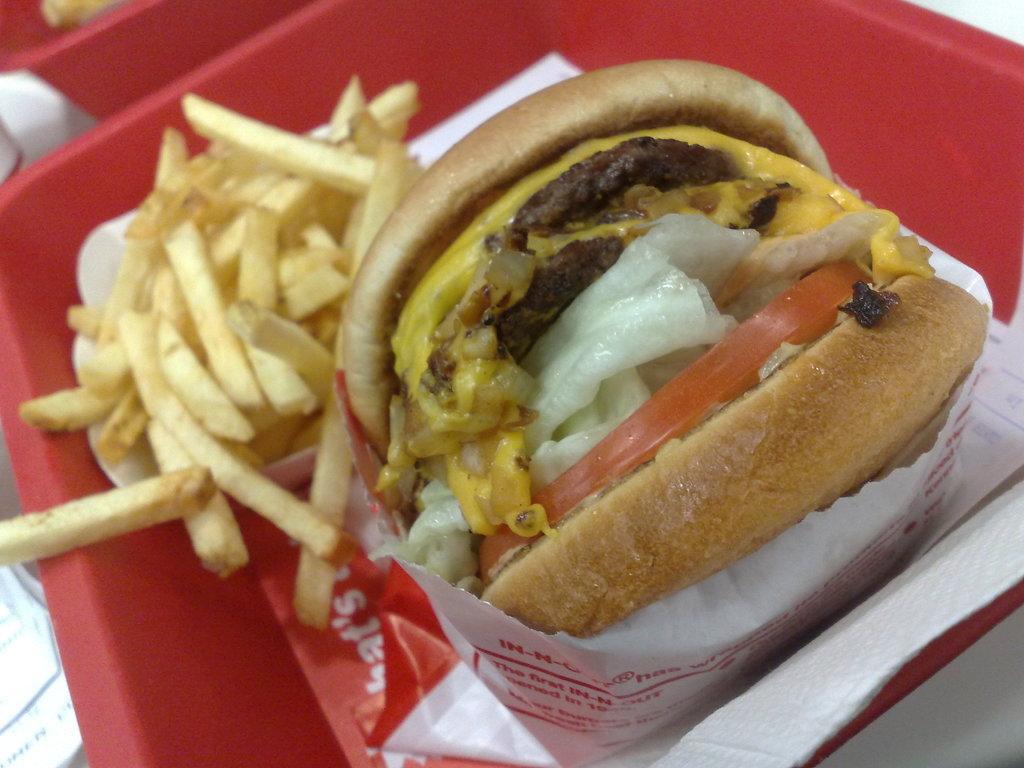Can you describe this image briefly? In this image there is the food in the plate. In the center there is a burger wrapped in the paper. Beside it there are french fries. 